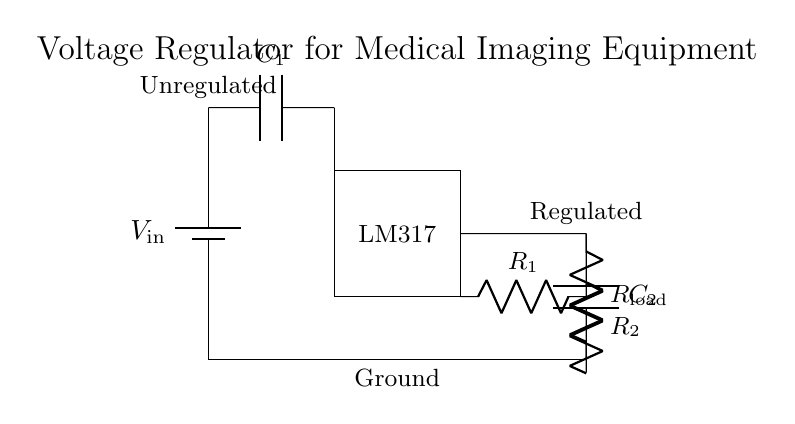What type of voltage regulator is used in this circuit? The circuit shows an LM317 voltage regulator, which is indicated by the rectangle labeled "LM317". This is a common adjustable voltage regulator used in various applications.
Answer: LM317 What are the functions of capacitors C1 and C2? Capacitor C1 (input capacitor) stabilizes the input voltage to the regulator, while capacitor C2 (output capacitor) smooths the output voltage to reduce fluctuations. Both capacitors enhance performance and stability of the circuit.
Answer: Stabilization and smoothing What are the values of the resistors R1 and R2 used for? Resistor R1 and R2 form a voltage divider that sets the output voltage level of the LM317. The specific values of R1 and R2 determine the output voltage based on the formula provided in the LM317 datasheet.
Answer: Voltage divider What is the purpose of the battery in the circuit? The battery serves as the input voltage source (V_in) for the voltage regulator, providing the necessary power for the circuit to operate. Its voltage must be higher than the desired output voltage for proper regulation.
Answer: Input voltage source How does the output voltage relate to V_in? The output voltage is regulated to a specific value less than V_in, depending on the resistor values. The LM317 maintains a constant output voltage, determined by the feedback from R1 and R2.
Answer: Regulated voltage What is the ground reference point in this circuit? The ground reference point is indicated by the line at the bottom (y=0), which connects to the battery and load resistor. This ensures all voltages in the circuit are measured with respect to this common point.
Answer: Bottom line What would happen if C2 were removed from the circuit? If C2 is removed, the output voltage may become unstable and experience higher ripple voltage due to fluctuations in the load current. This can affect the performance of medical imaging equipment, resulting in inaccurate readings.
Answer: Increased ripple 